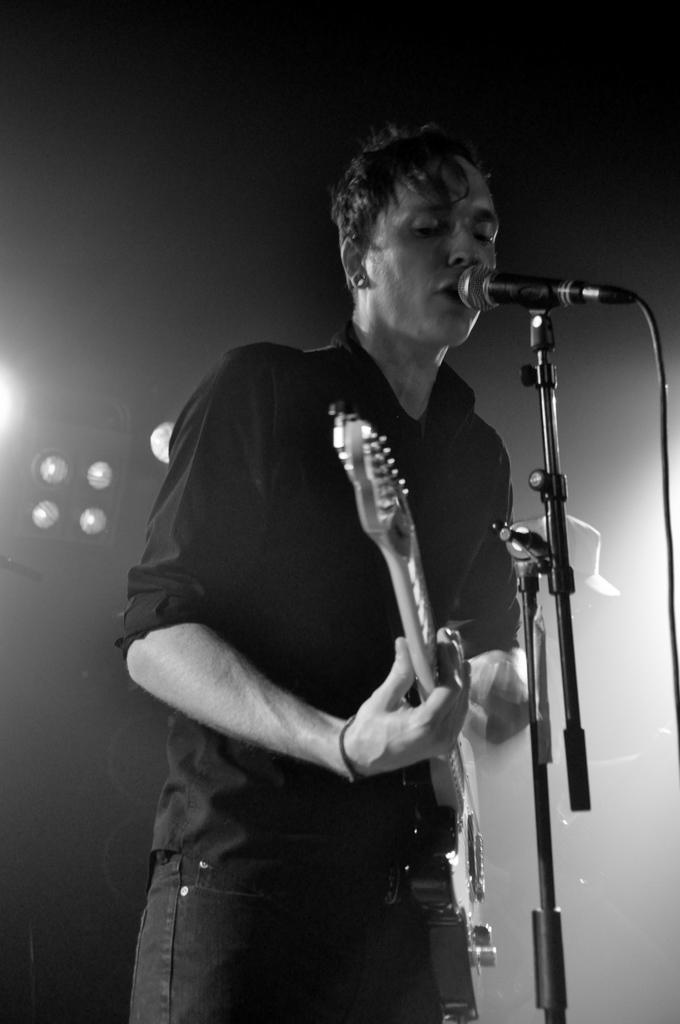Describe this image in one or two sentences. The man with the black shirt is standing and he is playing guitar. In front of him there is a mic. And to the left corner we can see lights. 